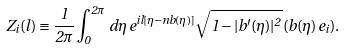Convert formula to latex. <formula><loc_0><loc_0><loc_500><loc_500>Z _ { i } ( l ) \equiv \frac { 1 } { 2 \pi } \int _ { 0 } ^ { 2 \pi } \, d \eta \, e ^ { i l [ \eta - n b ( \eta ) ] } \sqrt { 1 - | b ^ { \prime } ( \eta ) | ^ { 2 } } \, ( b ( \eta ) \, e _ { i } ) .</formula> 